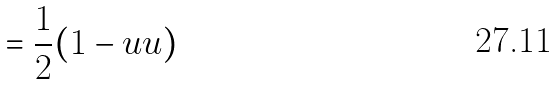<formula> <loc_0><loc_0><loc_500><loc_500>= { \frac { 1 } { 2 } } ( 1 - u u )</formula> 